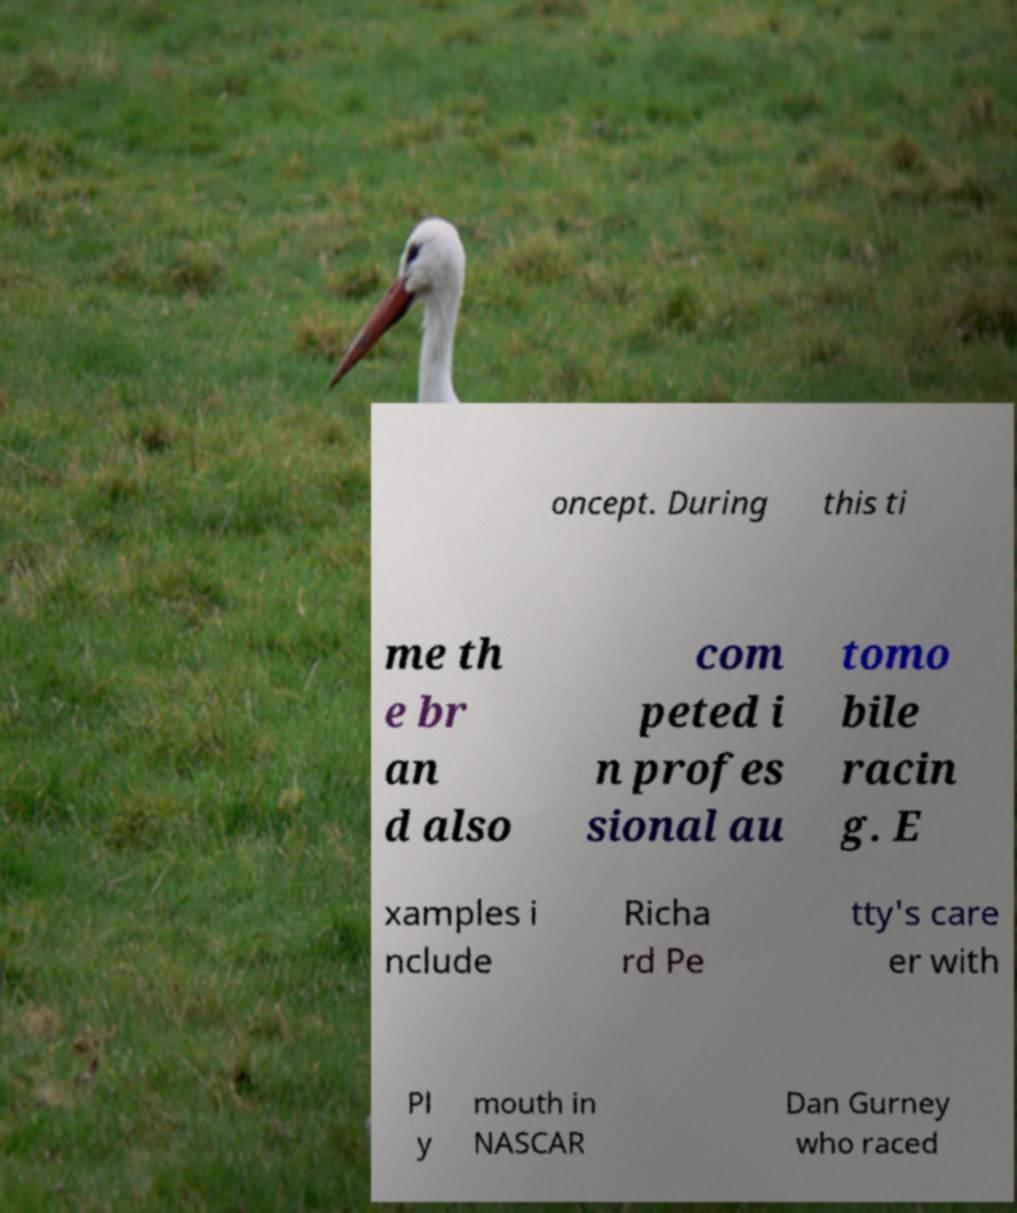I need the written content from this picture converted into text. Can you do that? oncept. During this ti me th e br an d also com peted i n profes sional au tomo bile racin g. E xamples i nclude Richa rd Pe tty's care er with Pl y mouth in NASCAR Dan Gurney who raced 